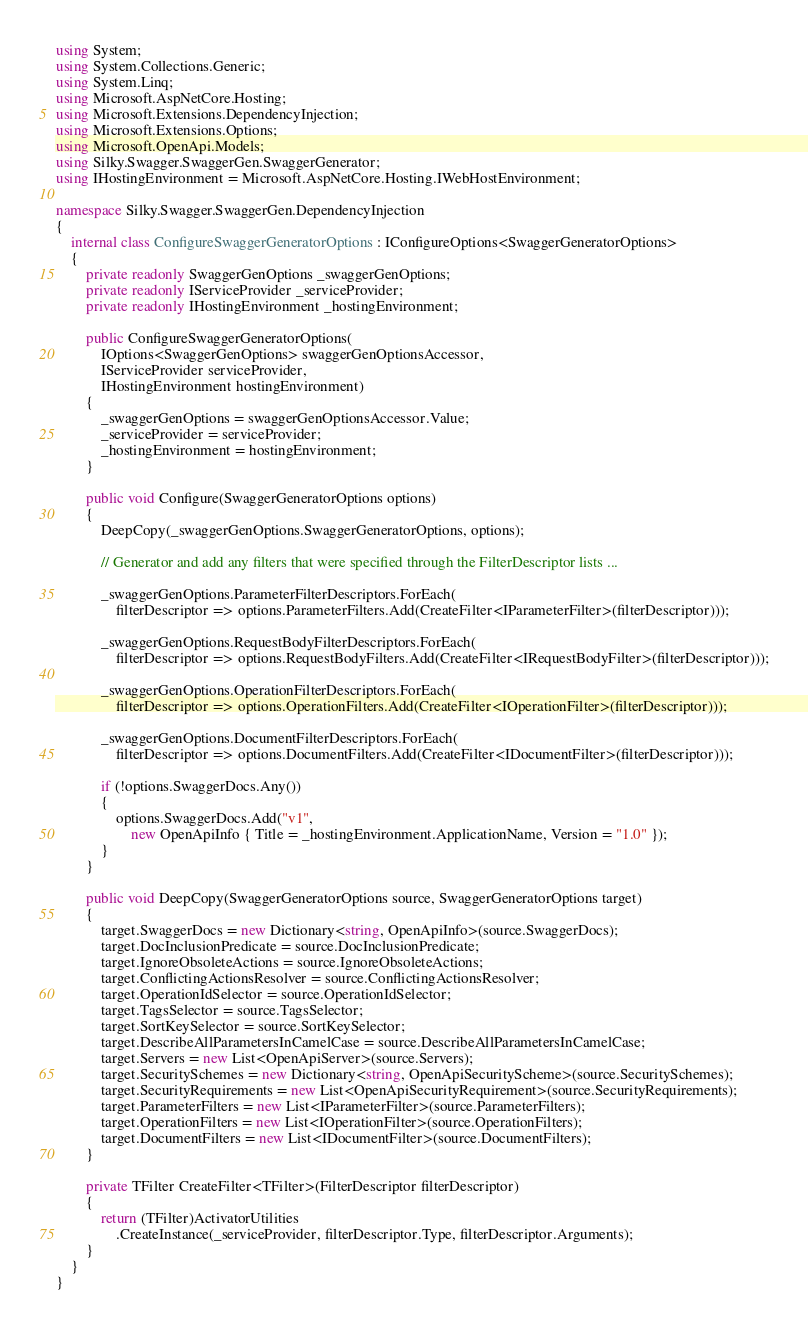<code> <loc_0><loc_0><loc_500><loc_500><_C#_>using System;
using System.Collections.Generic;
using System.Linq;
using Microsoft.AspNetCore.Hosting;
using Microsoft.Extensions.DependencyInjection;
using Microsoft.Extensions.Options;
using Microsoft.OpenApi.Models;
using Silky.Swagger.SwaggerGen.SwaggerGenerator;
using IHostingEnvironment = Microsoft.AspNetCore.Hosting.IWebHostEnvironment;

namespace Silky.Swagger.SwaggerGen.DependencyInjection
{
    internal class ConfigureSwaggerGeneratorOptions : IConfigureOptions<SwaggerGeneratorOptions>
    {
        private readonly SwaggerGenOptions _swaggerGenOptions;
        private readonly IServiceProvider _serviceProvider;
        private readonly IHostingEnvironment _hostingEnvironment;

        public ConfigureSwaggerGeneratorOptions(
            IOptions<SwaggerGenOptions> swaggerGenOptionsAccessor,
            IServiceProvider serviceProvider,
            IHostingEnvironment hostingEnvironment)
        {
            _swaggerGenOptions = swaggerGenOptionsAccessor.Value;
            _serviceProvider = serviceProvider;
            _hostingEnvironment = hostingEnvironment;
        }

        public void Configure(SwaggerGeneratorOptions options)
        {
            DeepCopy(_swaggerGenOptions.SwaggerGeneratorOptions, options);

            // Generator and add any filters that were specified through the FilterDescriptor lists ...

            _swaggerGenOptions.ParameterFilterDescriptors.ForEach(
                filterDescriptor => options.ParameterFilters.Add(CreateFilter<IParameterFilter>(filterDescriptor)));

            _swaggerGenOptions.RequestBodyFilterDescriptors.ForEach(
                filterDescriptor => options.RequestBodyFilters.Add(CreateFilter<IRequestBodyFilter>(filterDescriptor)));

            _swaggerGenOptions.OperationFilterDescriptors.ForEach(
                filterDescriptor => options.OperationFilters.Add(CreateFilter<IOperationFilter>(filterDescriptor)));

            _swaggerGenOptions.DocumentFilterDescriptors.ForEach(
                filterDescriptor => options.DocumentFilters.Add(CreateFilter<IDocumentFilter>(filterDescriptor)));

            if (!options.SwaggerDocs.Any())
            {
                options.SwaggerDocs.Add("v1",
                    new OpenApiInfo { Title = _hostingEnvironment.ApplicationName, Version = "1.0" });
            }
        }

        public void DeepCopy(SwaggerGeneratorOptions source, SwaggerGeneratorOptions target)
        {
            target.SwaggerDocs = new Dictionary<string, OpenApiInfo>(source.SwaggerDocs);
            target.DocInclusionPredicate = source.DocInclusionPredicate;
            target.IgnoreObsoleteActions = source.IgnoreObsoleteActions;
            target.ConflictingActionsResolver = source.ConflictingActionsResolver;
            target.OperationIdSelector = source.OperationIdSelector;
            target.TagsSelector = source.TagsSelector;
            target.SortKeySelector = source.SortKeySelector;
            target.DescribeAllParametersInCamelCase = source.DescribeAllParametersInCamelCase;
            target.Servers = new List<OpenApiServer>(source.Servers);
            target.SecuritySchemes = new Dictionary<string, OpenApiSecurityScheme>(source.SecuritySchemes);
            target.SecurityRequirements = new List<OpenApiSecurityRequirement>(source.SecurityRequirements);
            target.ParameterFilters = new List<IParameterFilter>(source.ParameterFilters);
            target.OperationFilters = new List<IOperationFilter>(source.OperationFilters);
            target.DocumentFilters = new List<IDocumentFilter>(source.DocumentFilters);
        }

        private TFilter CreateFilter<TFilter>(FilterDescriptor filterDescriptor)
        {
            return (TFilter)ActivatorUtilities
                .CreateInstance(_serviceProvider, filterDescriptor.Type, filterDescriptor.Arguments);
        }
    }
}</code> 